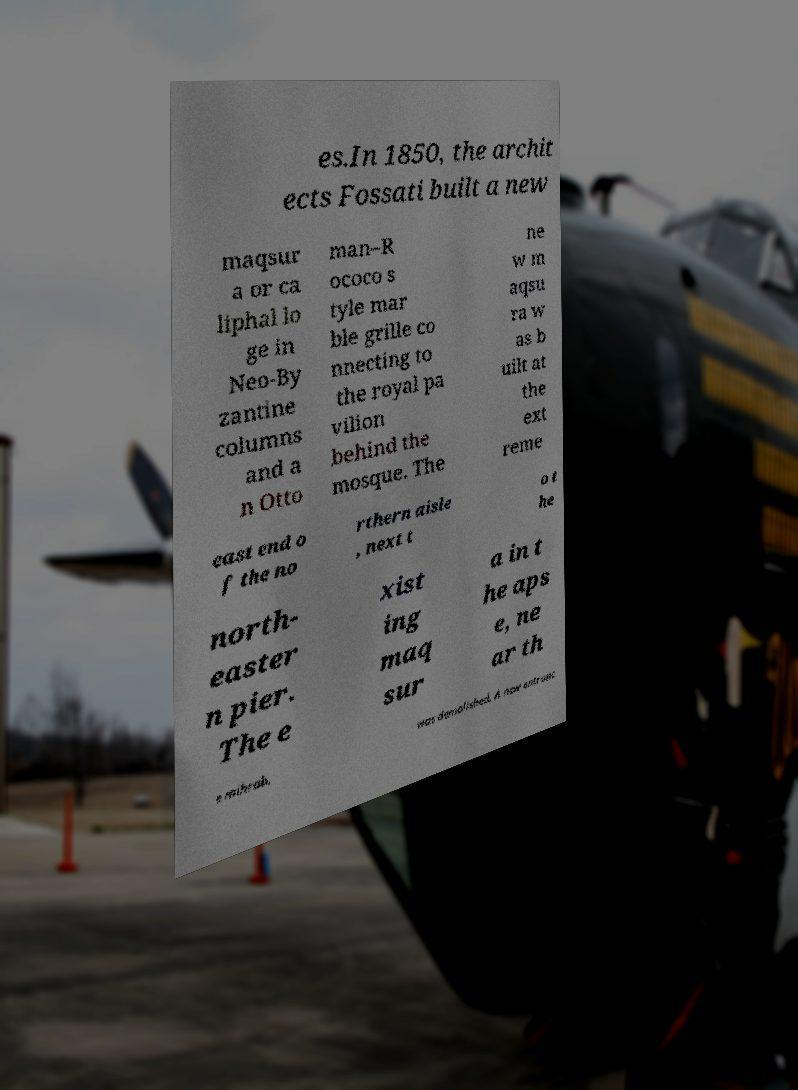Could you assist in decoding the text presented in this image and type it out clearly? es.In 1850, the archit ects Fossati built a new maqsur a or ca liphal lo ge in Neo-By zantine columns and a n Otto man–R ococo s tyle mar ble grille co nnecting to the royal pa vilion behind the mosque. The ne w m aqsu ra w as b uilt at the ext reme east end o f the no rthern aisle , next t o t he north- easter n pier. The e xist ing maq sur a in t he aps e, ne ar th e mihrab, was demolished. A new entranc 